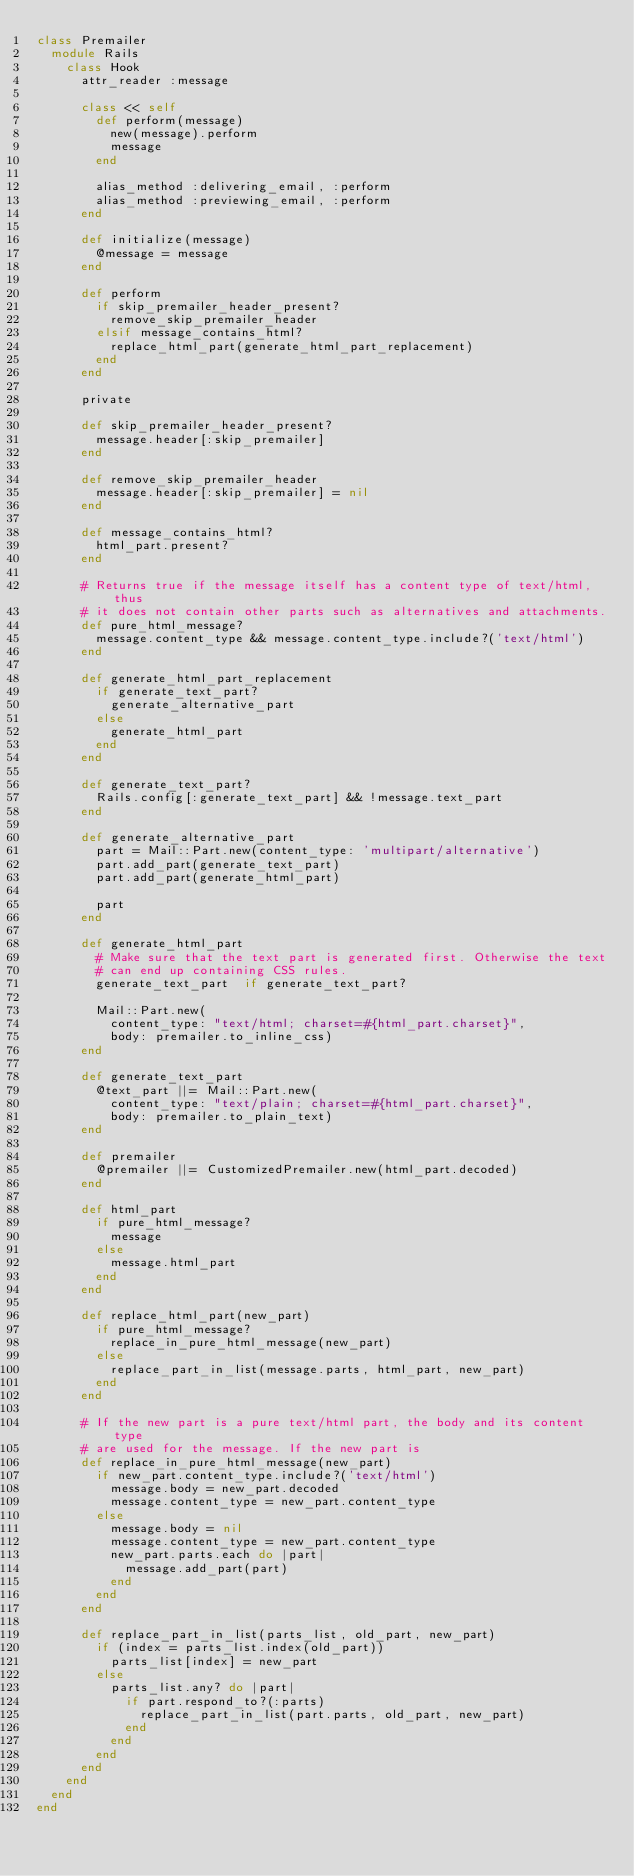<code> <loc_0><loc_0><loc_500><loc_500><_Ruby_>class Premailer
  module Rails
    class Hook
      attr_reader :message

      class << self
        def perform(message)
          new(message).perform
          message
        end

        alias_method :delivering_email, :perform
        alias_method :previewing_email, :perform
      end

      def initialize(message)
        @message = message
      end

      def perform
        if skip_premailer_header_present?
          remove_skip_premailer_header
        elsif message_contains_html?
          replace_html_part(generate_html_part_replacement)
        end
      end

      private

      def skip_premailer_header_present?
        message.header[:skip_premailer]
      end

      def remove_skip_premailer_header
        message.header[:skip_premailer] = nil
      end

      def message_contains_html?
        html_part.present?
      end

      # Returns true if the message itself has a content type of text/html, thus
      # it does not contain other parts such as alternatives and attachments.
      def pure_html_message?
        message.content_type && message.content_type.include?('text/html')
      end

      def generate_html_part_replacement
        if generate_text_part?
          generate_alternative_part
        else
          generate_html_part
        end
      end

      def generate_text_part?
        Rails.config[:generate_text_part] && !message.text_part
      end

      def generate_alternative_part
        part = Mail::Part.new(content_type: 'multipart/alternative')
        part.add_part(generate_text_part)
        part.add_part(generate_html_part)

        part
      end

      def generate_html_part
        # Make sure that the text part is generated first. Otherwise the text
        # can end up containing CSS rules.
        generate_text_part  if generate_text_part?

        Mail::Part.new(
          content_type: "text/html; charset=#{html_part.charset}",
          body: premailer.to_inline_css)
      end

      def generate_text_part
        @text_part ||= Mail::Part.new(
          content_type: "text/plain; charset=#{html_part.charset}",
          body: premailer.to_plain_text)
      end

      def premailer
        @premailer ||= CustomizedPremailer.new(html_part.decoded)
      end

      def html_part
        if pure_html_message?
          message
        else
          message.html_part
        end
      end

      def replace_html_part(new_part)
        if pure_html_message?
          replace_in_pure_html_message(new_part)
        else
          replace_part_in_list(message.parts, html_part, new_part)
        end
      end

      # If the new part is a pure text/html part, the body and its content type
      # are used for the message. If the new part is
      def replace_in_pure_html_message(new_part)
        if new_part.content_type.include?('text/html')
          message.body = new_part.decoded
          message.content_type = new_part.content_type
        else
          message.body = nil
          message.content_type = new_part.content_type
          new_part.parts.each do |part|
            message.add_part(part)
          end
        end
      end

      def replace_part_in_list(parts_list, old_part, new_part)
        if (index = parts_list.index(old_part))
          parts_list[index] = new_part
        else
          parts_list.any? do |part|
            if part.respond_to?(:parts)
              replace_part_in_list(part.parts, old_part, new_part)
            end
          end
        end
      end
    end
  end
end
</code> 